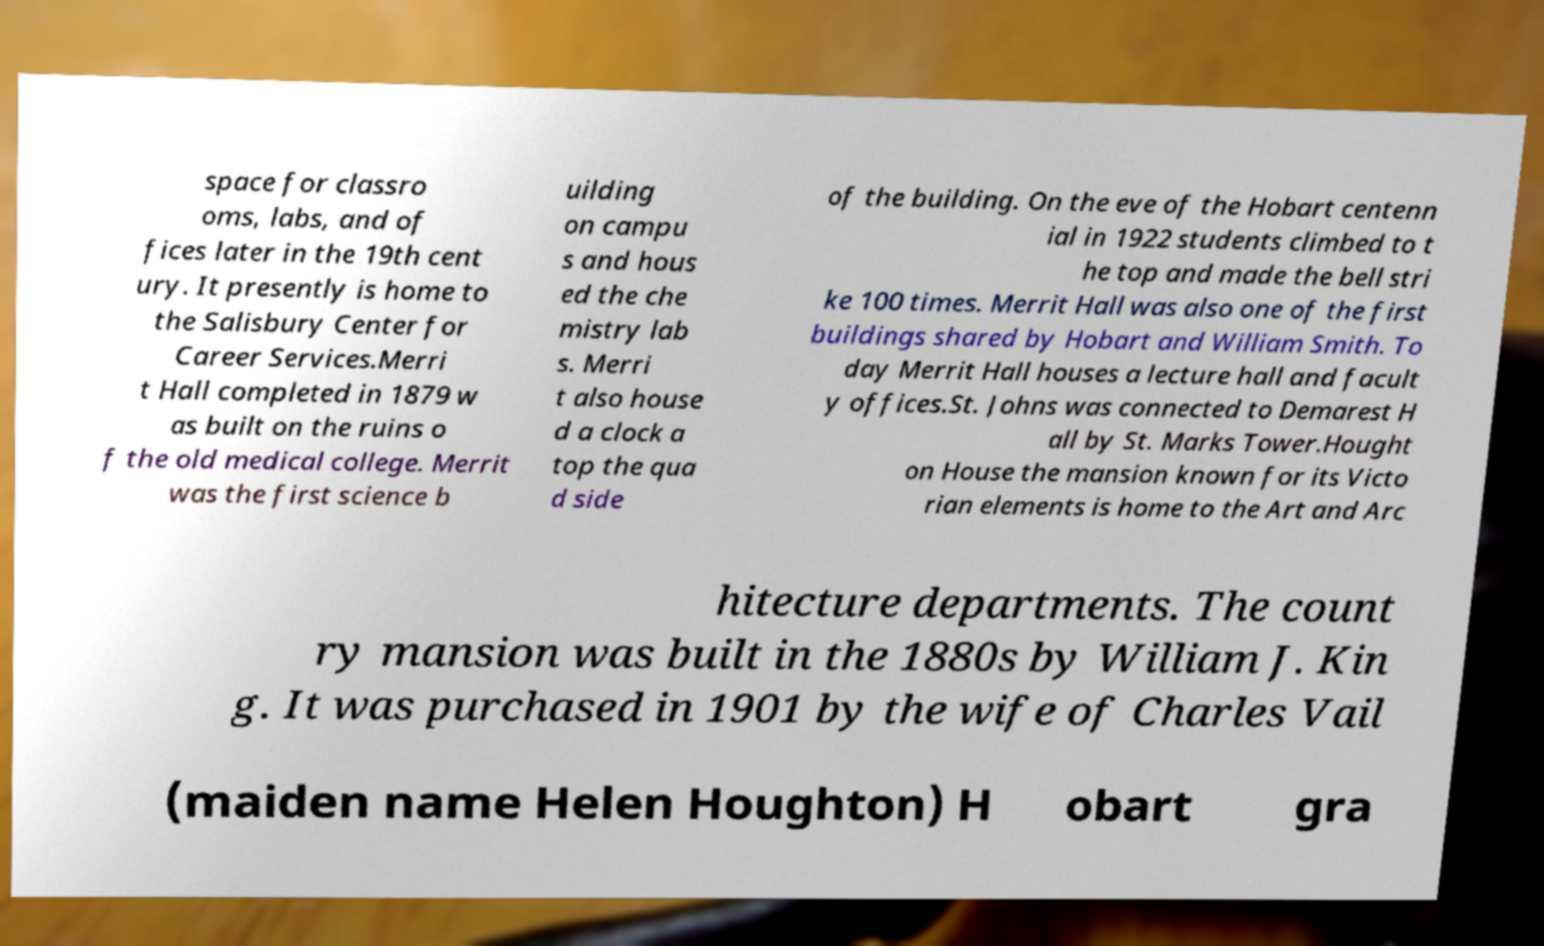Can you accurately transcribe the text from the provided image for me? space for classro oms, labs, and of fices later in the 19th cent ury. It presently is home to the Salisbury Center for Career Services.Merri t Hall completed in 1879 w as built on the ruins o f the old medical college. Merrit was the first science b uilding on campu s and hous ed the che mistry lab s. Merri t also house d a clock a top the qua d side of the building. On the eve of the Hobart centenn ial in 1922 students climbed to t he top and made the bell stri ke 100 times. Merrit Hall was also one of the first buildings shared by Hobart and William Smith. To day Merrit Hall houses a lecture hall and facult y offices.St. Johns was connected to Demarest H all by St. Marks Tower.Hought on House the mansion known for its Victo rian elements is home to the Art and Arc hitecture departments. The count ry mansion was built in the 1880s by William J. Kin g. It was purchased in 1901 by the wife of Charles Vail (maiden name Helen Houghton) H obart gra 